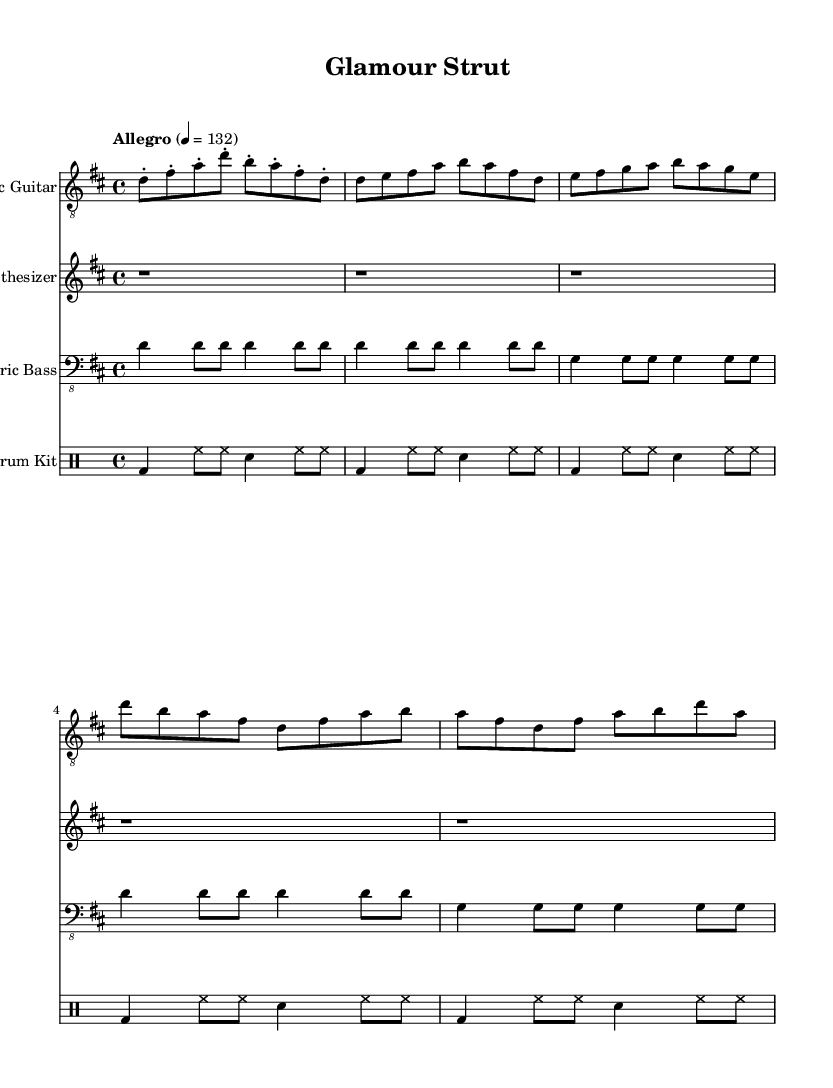What is the key signature of this music? The key signature is D major, which has two sharps (F# and C#). This can be determined from the key signature at the beginning of the sheet music.
Answer: D major What is the time signature of this music? The time signature is four-four, indicated by the "4/4" notation placed at the start of the piece. This indicates that there are four beats per measure and that the quarter note gets one beat.
Answer: 4/4 What is the tempo marking of this music? The tempo marking is "Allegro," which suggests a fast and lively pace. The specific beats per minute (BPM) indicated is 132, and this can be found next to the tempo marking at the beginning.
Answer: Allegro How many sections are there in this piece? There are three sections: Intro, Verse, and Chorus. Each section displays distinct patterns for the instruments, helping to structure the piece and maintain energy and dynamics throughout.
Answer: Three What instruments are present in this music? The instruments present are Electric Guitar, Synthesizer, Electric Bass, and Drum Kit. Each instrument has its own staff in the score, indicating their specific musical lines.
Answer: Electric Guitar, Synthesizer, Electric Bass, Drum Kit What rhythm pattern is primarily used in the drum kit during the verse? The primary rhythm pattern in the drum kit during the verse is a bass drum, hi-hat, and snare pattern, with the bass drum playing on the first beat and alternating with hi-hats and snare hits. This can be seen in the drum notation for the verse section.
Answer: Bass drum, hi-hat, snare 